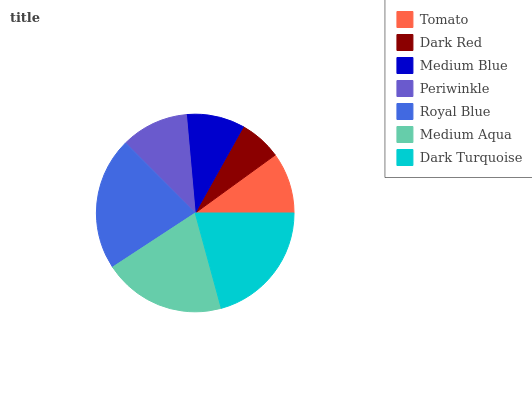Is Dark Red the minimum?
Answer yes or no. Yes. Is Royal Blue the maximum?
Answer yes or no. Yes. Is Medium Blue the minimum?
Answer yes or no. No. Is Medium Blue the maximum?
Answer yes or no. No. Is Medium Blue greater than Dark Red?
Answer yes or no. Yes. Is Dark Red less than Medium Blue?
Answer yes or no. Yes. Is Dark Red greater than Medium Blue?
Answer yes or no. No. Is Medium Blue less than Dark Red?
Answer yes or no. No. Is Periwinkle the high median?
Answer yes or no. Yes. Is Periwinkle the low median?
Answer yes or no. Yes. Is Dark Red the high median?
Answer yes or no. No. Is Dark Turquoise the low median?
Answer yes or no. No. 